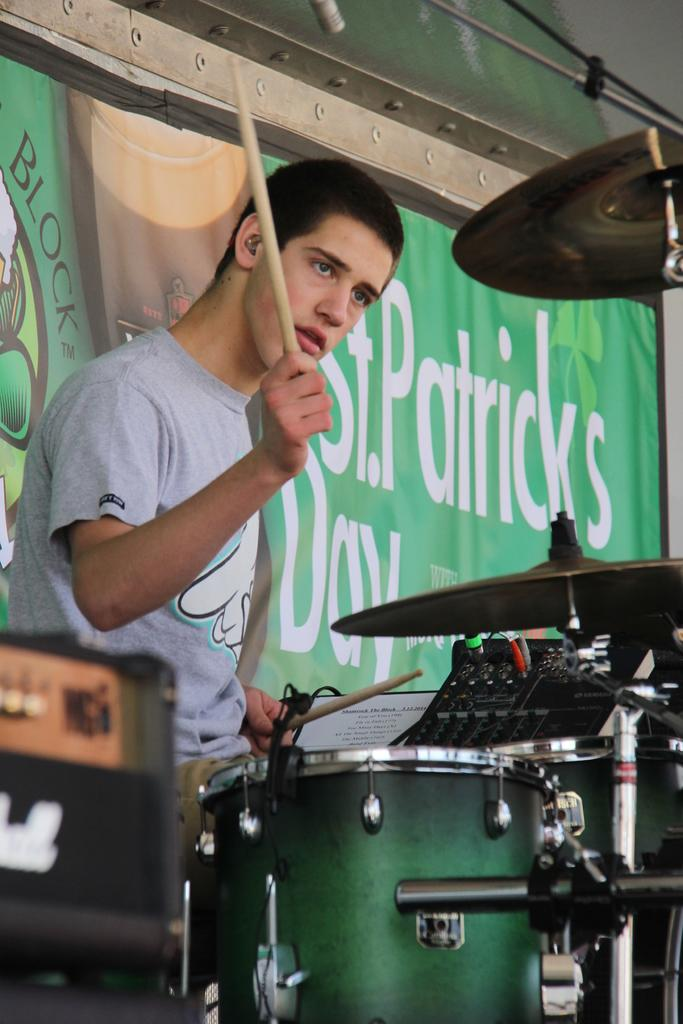Who is the person in the image? There is a man in the image. What is the man wearing? The man is wearing a t-shirt. What is the man doing in the image? The man is playing the drums. What can be seen in the background of the image? There is a banner in the background of the image. What is the man using to play the drums? The man is holding sticks in his hands. Where is the kitten sitting on the throne in the image? There is no kitten or throne present in the image. 